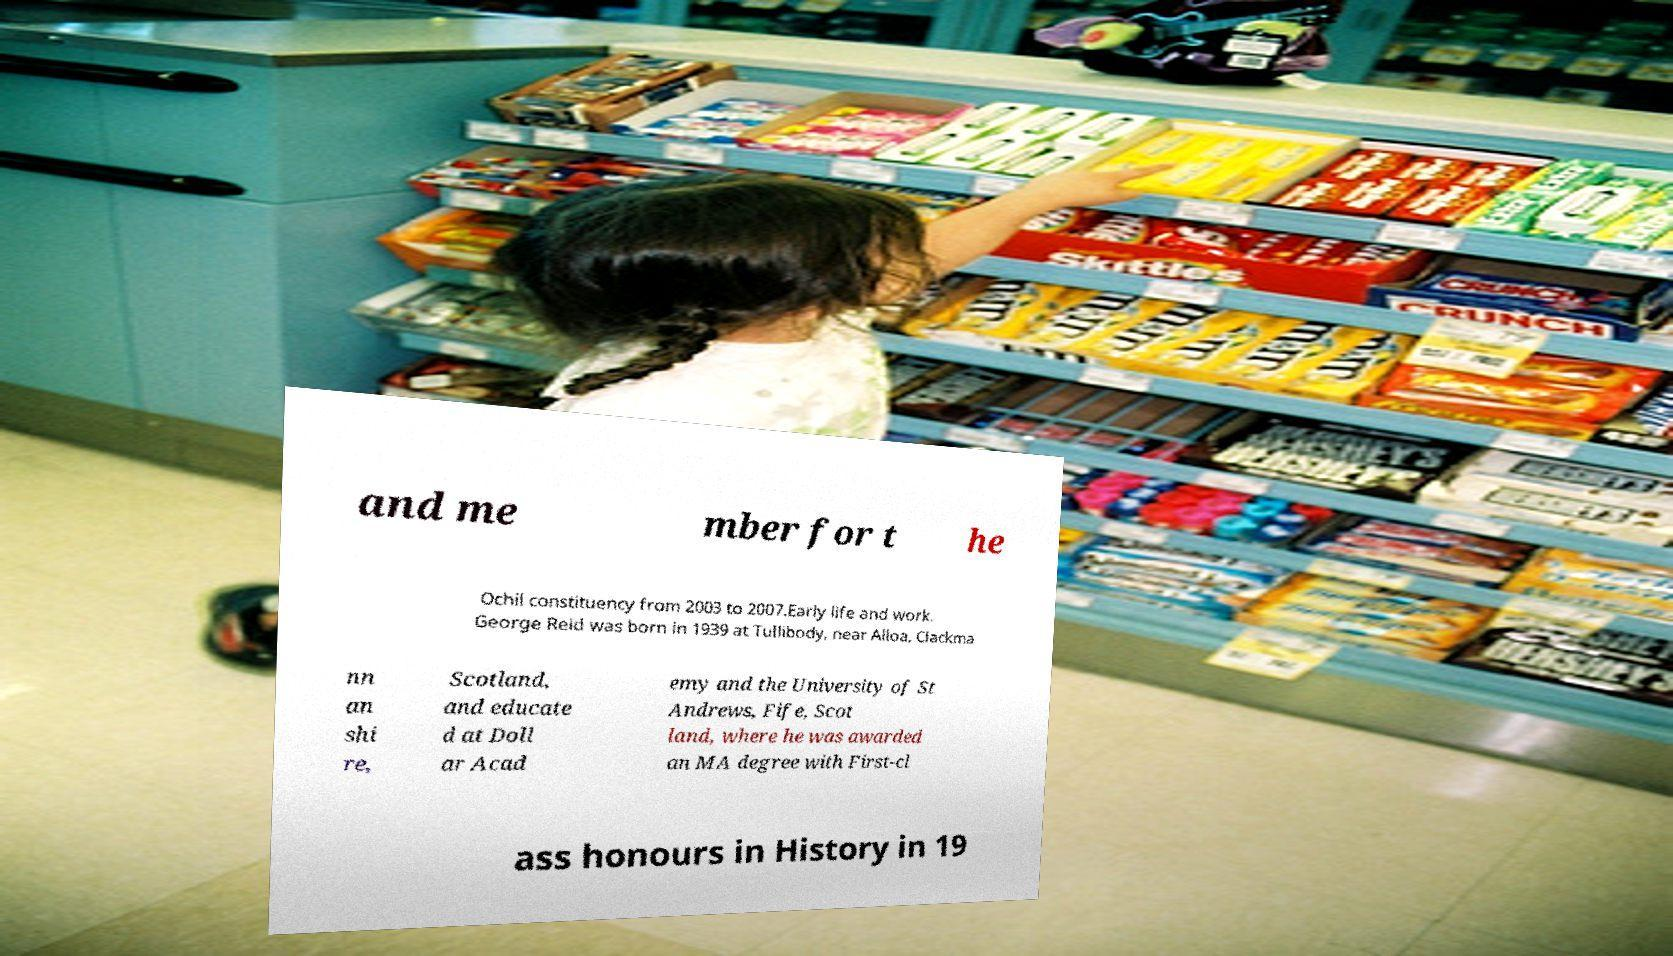What messages or text are displayed in this image? I need them in a readable, typed format. and me mber for t he Ochil constituency from 2003 to 2007.Early life and work. George Reid was born in 1939 at Tullibody, near Alloa, Clackma nn an shi re, Scotland, and educate d at Doll ar Acad emy and the University of St Andrews, Fife, Scot land, where he was awarded an MA degree with First-cl ass honours in History in 19 